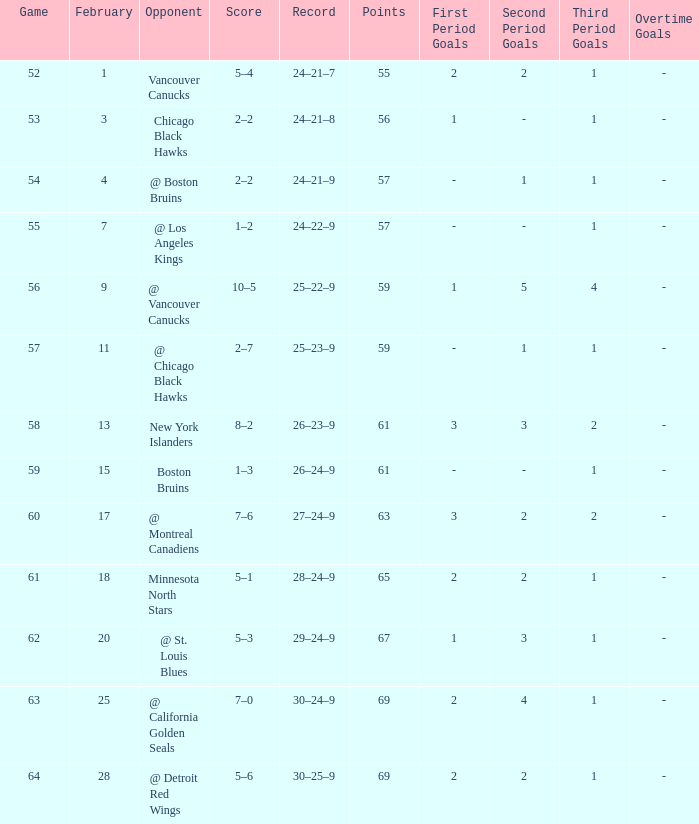How many games have a record of 30–25–9 and more points than 69? 0.0. 